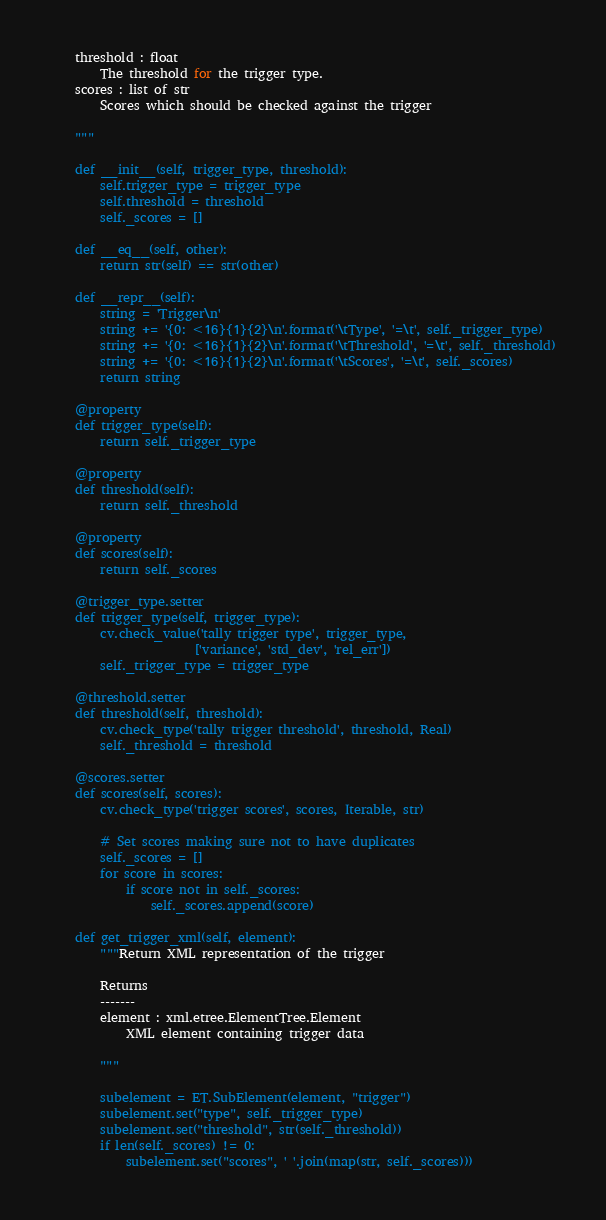<code> <loc_0><loc_0><loc_500><loc_500><_Python_>    threshold : float
        The threshold for the trigger type.
    scores : list of str
        Scores which should be checked against the trigger

    """

    def __init__(self, trigger_type, threshold):
        self.trigger_type = trigger_type
        self.threshold = threshold
        self._scores = []

    def __eq__(self, other):
        return str(self) == str(other)

    def __repr__(self):
        string = 'Trigger\n'
        string += '{0: <16}{1}{2}\n'.format('\tType', '=\t', self._trigger_type)
        string += '{0: <16}{1}{2}\n'.format('\tThreshold', '=\t', self._threshold)
        string += '{0: <16}{1}{2}\n'.format('\tScores', '=\t', self._scores)
        return string

    @property
    def trigger_type(self):
        return self._trigger_type

    @property
    def threshold(self):
        return self._threshold

    @property
    def scores(self):
        return self._scores

    @trigger_type.setter
    def trigger_type(self, trigger_type):
        cv.check_value('tally trigger type', trigger_type,
                       ['variance', 'std_dev', 'rel_err'])
        self._trigger_type = trigger_type

    @threshold.setter
    def threshold(self, threshold):
        cv.check_type('tally trigger threshold', threshold, Real)
        self._threshold = threshold

    @scores.setter
    def scores(self, scores):
        cv.check_type('trigger scores', scores, Iterable, str)

        # Set scores making sure not to have duplicates
        self._scores = []
        for score in scores:
            if score not in self._scores:
                self._scores.append(score)

    def get_trigger_xml(self, element):
        """Return XML representation of the trigger

        Returns
        -------
        element : xml.etree.ElementTree.Element
            XML element containing trigger data

        """

        subelement = ET.SubElement(element, "trigger")
        subelement.set("type", self._trigger_type)
        subelement.set("threshold", str(self._threshold))
        if len(self._scores) != 0:
            subelement.set("scores", ' '.join(map(str, self._scores)))
</code> 